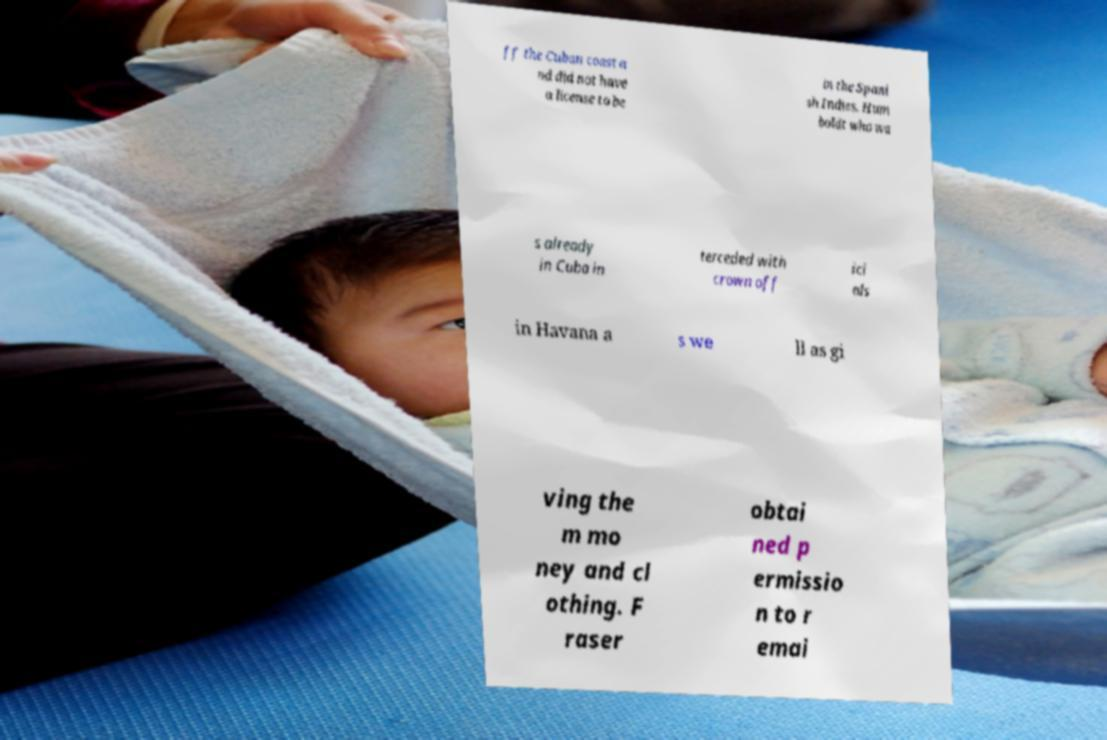Can you read and provide the text displayed in the image?This photo seems to have some interesting text. Can you extract and type it out for me? ff the Cuban coast a nd did not have a license to be in the Spani sh Indies. Hum boldt who wa s already in Cuba in terceded with crown off ici als in Havana a s we ll as gi ving the m mo ney and cl othing. F raser obtai ned p ermissio n to r emai 